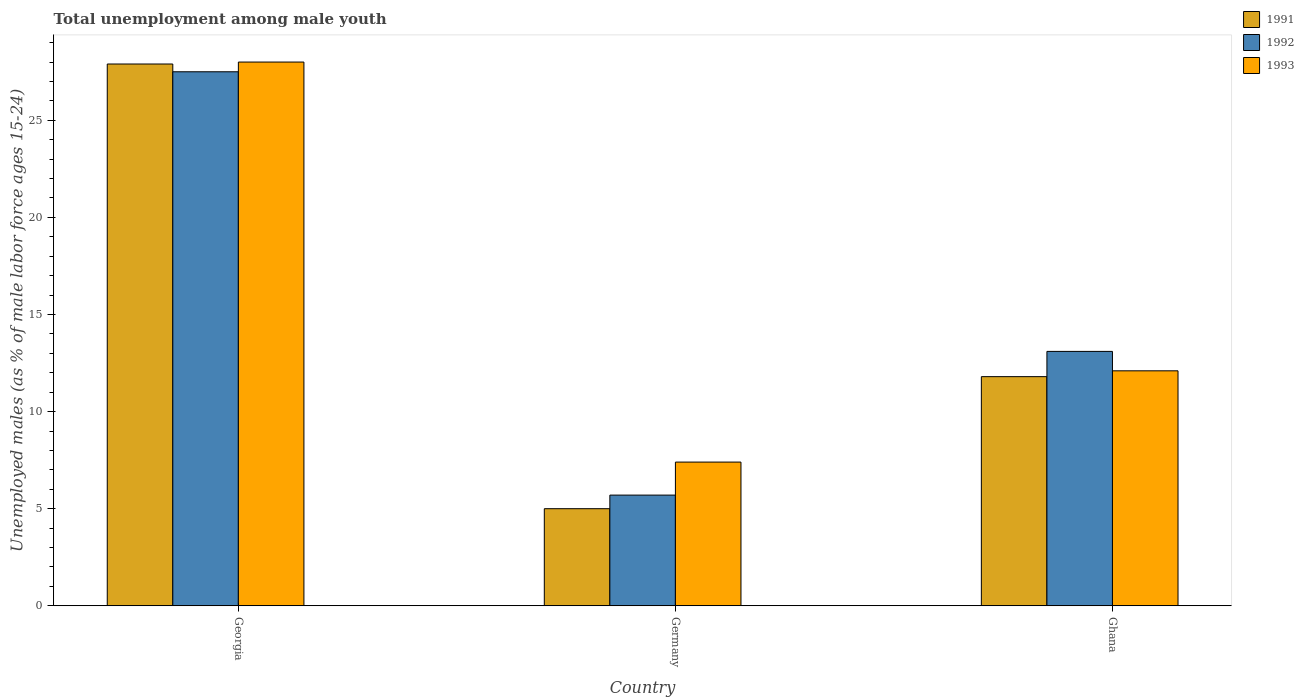How many different coloured bars are there?
Offer a very short reply. 3. Are the number of bars per tick equal to the number of legend labels?
Provide a succinct answer. Yes. How many bars are there on the 3rd tick from the left?
Give a very brief answer. 3. How many bars are there on the 3rd tick from the right?
Offer a terse response. 3. What is the label of the 2nd group of bars from the left?
Provide a succinct answer. Germany. What is the percentage of unemployed males in in 1993 in Ghana?
Ensure brevity in your answer.  12.1. Across all countries, what is the maximum percentage of unemployed males in in 1992?
Make the answer very short. 27.5. Across all countries, what is the minimum percentage of unemployed males in in 1992?
Provide a succinct answer. 5.7. In which country was the percentage of unemployed males in in 1993 maximum?
Your response must be concise. Georgia. What is the total percentage of unemployed males in in 1993 in the graph?
Your answer should be compact. 47.5. What is the difference between the percentage of unemployed males in in 1992 in Georgia and that in Ghana?
Your answer should be compact. 14.4. What is the difference between the percentage of unemployed males in in 1993 in Ghana and the percentage of unemployed males in in 1991 in Germany?
Make the answer very short. 7.1. What is the average percentage of unemployed males in in 1991 per country?
Provide a succinct answer. 14.9. In how many countries, is the percentage of unemployed males in in 1992 greater than 4 %?
Offer a very short reply. 3. What is the ratio of the percentage of unemployed males in in 1991 in Germany to that in Ghana?
Your answer should be compact. 0.42. What is the difference between the highest and the second highest percentage of unemployed males in in 1991?
Give a very brief answer. -16.1. What is the difference between the highest and the lowest percentage of unemployed males in in 1993?
Provide a short and direct response. 20.6. In how many countries, is the percentage of unemployed males in in 1993 greater than the average percentage of unemployed males in in 1993 taken over all countries?
Make the answer very short. 1. What does the 3rd bar from the left in Georgia represents?
Provide a short and direct response. 1993. What does the 3rd bar from the right in Ghana represents?
Provide a short and direct response. 1991. How many bars are there?
Give a very brief answer. 9. Are all the bars in the graph horizontal?
Ensure brevity in your answer.  No. Does the graph contain any zero values?
Your answer should be compact. No. Does the graph contain grids?
Your answer should be compact. No. How many legend labels are there?
Give a very brief answer. 3. What is the title of the graph?
Make the answer very short. Total unemployment among male youth. Does "1960" appear as one of the legend labels in the graph?
Ensure brevity in your answer.  No. What is the label or title of the Y-axis?
Make the answer very short. Unemployed males (as % of male labor force ages 15-24). What is the Unemployed males (as % of male labor force ages 15-24) of 1991 in Georgia?
Ensure brevity in your answer.  27.9. What is the Unemployed males (as % of male labor force ages 15-24) of 1991 in Germany?
Give a very brief answer. 5. What is the Unemployed males (as % of male labor force ages 15-24) of 1992 in Germany?
Give a very brief answer. 5.7. What is the Unemployed males (as % of male labor force ages 15-24) in 1993 in Germany?
Your answer should be very brief. 7.4. What is the Unemployed males (as % of male labor force ages 15-24) of 1991 in Ghana?
Ensure brevity in your answer.  11.8. What is the Unemployed males (as % of male labor force ages 15-24) of 1992 in Ghana?
Your answer should be compact. 13.1. What is the Unemployed males (as % of male labor force ages 15-24) of 1993 in Ghana?
Your answer should be very brief. 12.1. Across all countries, what is the maximum Unemployed males (as % of male labor force ages 15-24) of 1991?
Offer a very short reply. 27.9. Across all countries, what is the maximum Unemployed males (as % of male labor force ages 15-24) in 1992?
Your response must be concise. 27.5. Across all countries, what is the maximum Unemployed males (as % of male labor force ages 15-24) of 1993?
Offer a terse response. 28. Across all countries, what is the minimum Unemployed males (as % of male labor force ages 15-24) of 1992?
Give a very brief answer. 5.7. Across all countries, what is the minimum Unemployed males (as % of male labor force ages 15-24) of 1993?
Provide a succinct answer. 7.4. What is the total Unemployed males (as % of male labor force ages 15-24) in 1991 in the graph?
Provide a succinct answer. 44.7. What is the total Unemployed males (as % of male labor force ages 15-24) in 1992 in the graph?
Keep it short and to the point. 46.3. What is the total Unemployed males (as % of male labor force ages 15-24) in 1993 in the graph?
Keep it short and to the point. 47.5. What is the difference between the Unemployed males (as % of male labor force ages 15-24) in 1991 in Georgia and that in Germany?
Your response must be concise. 22.9. What is the difference between the Unemployed males (as % of male labor force ages 15-24) of 1992 in Georgia and that in Germany?
Your response must be concise. 21.8. What is the difference between the Unemployed males (as % of male labor force ages 15-24) in 1993 in Georgia and that in Germany?
Keep it short and to the point. 20.6. What is the difference between the Unemployed males (as % of male labor force ages 15-24) of 1991 in Georgia and that in Ghana?
Ensure brevity in your answer.  16.1. What is the difference between the Unemployed males (as % of male labor force ages 15-24) in 1992 in Georgia and that in Ghana?
Ensure brevity in your answer.  14.4. What is the difference between the Unemployed males (as % of male labor force ages 15-24) of 1993 in Georgia and that in Ghana?
Keep it short and to the point. 15.9. What is the difference between the Unemployed males (as % of male labor force ages 15-24) in 1993 in Germany and that in Ghana?
Your answer should be compact. -4.7. What is the difference between the Unemployed males (as % of male labor force ages 15-24) of 1992 in Georgia and the Unemployed males (as % of male labor force ages 15-24) of 1993 in Germany?
Your answer should be compact. 20.1. What is the difference between the Unemployed males (as % of male labor force ages 15-24) of 1991 in Georgia and the Unemployed males (as % of male labor force ages 15-24) of 1992 in Ghana?
Ensure brevity in your answer.  14.8. What is the difference between the Unemployed males (as % of male labor force ages 15-24) of 1992 in Georgia and the Unemployed males (as % of male labor force ages 15-24) of 1993 in Ghana?
Your answer should be compact. 15.4. What is the average Unemployed males (as % of male labor force ages 15-24) of 1992 per country?
Provide a succinct answer. 15.43. What is the average Unemployed males (as % of male labor force ages 15-24) in 1993 per country?
Make the answer very short. 15.83. What is the difference between the Unemployed males (as % of male labor force ages 15-24) in 1991 and Unemployed males (as % of male labor force ages 15-24) in 1993 in Georgia?
Your response must be concise. -0.1. What is the difference between the Unemployed males (as % of male labor force ages 15-24) in 1991 and Unemployed males (as % of male labor force ages 15-24) in 1993 in Germany?
Provide a short and direct response. -2.4. What is the ratio of the Unemployed males (as % of male labor force ages 15-24) in 1991 in Georgia to that in Germany?
Give a very brief answer. 5.58. What is the ratio of the Unemployed males (as % of male labor force ages 15-24) in 1992 in Georgia to that in Germany?
Your answer should be compact. 4.82. What is the ratio of the Unemployed males (as % of male labor force ages 15-24) of 1993 in Georgia to that in Germany?
Provide a short and direct response. 3.78. What is the ratio of the Unemployed males (as % of male labor force ages 15-24) of 1991 in Georgia to that in Ghana?
Provide a succinct answer. 2.36. What is the ratio of the Unemployed males (as % of male labor force ages 15-24) in 1992 in Georgia to that in Ghana?
Your answer should be compact. 2.1. What is the ratio of the Unemployed males (as % of male labor force ages 15-24) in 1993 in Georgia to that in Ghana?
Your response must be concise. 2.31. What is the ratio of the Unemployed males (as % of male labor force ages 15-24) of 1991 in Germany to that in Ghana?
Offer a terse response. 0.42. What is the ratio of the Unemployed males (as % of male labor force ages 15-24) of 1992 in Germany to that in Ghana?
Provide a succinct answer. 0.44. What is the ratio of the Unemployed males (as % of male labor force ages 15-24) in 1993 in Germany to that in Ghana?
Provide a short and direct response. 0.61. What is the difference between the highest and the second highest Unemployed males (as % of male labor force ages 15-24) of 1991?
Keep it short and to the point. 16.1. What is the difference between the highest and the second highest Unemployed males (as % of male labor force ages 15-24) of 1992?
Keep it short and to the point. 14.4. What is the difference between the highest and the lowest Unemployed males (as % of male labor force ages 15-24) in 1991?
Ensure brevity in your answer.  22.9. What is the difference between the highest and the lowest Unemployed males (as % of male labor force ages 15-24) of 1992?
Offer a very short reply. 21.8. What is the difference between the highest and the lowest Unemployed males (as % of male labor force ages 15-24) in 1993?
Your answer should be very brief. 20.6. 